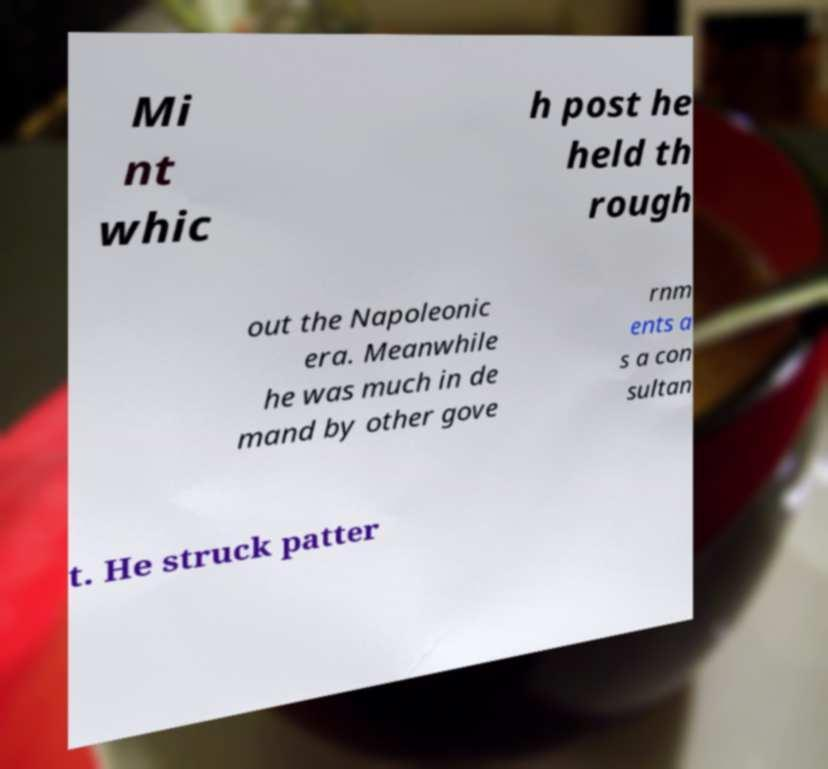What messages or text are displayed in this image? I need them in a readable, typed format. Mi nt whic h post he held th rough out the Napoleonic era. Meanwhile he was much in de mand by other gove rnm ents a s a con sultan t. He struck patter 